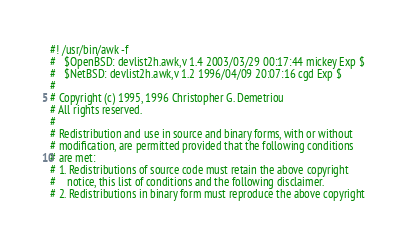Convert code to text. <code><loc_0><loc_0><loc_500><loc_500><_Awk_>#! /usr/bin/awk -f
#	$OpenBSD: devlist2h.awk,v 1.4 2003/03/29 00:17:44 mickey Exp $
#	$NetBSD: devlist2h.awk,v 1.2 1996/04/09 20:07:16 cgd Exp $
#
# Copyright (c) 1995, 1996 Christopher G. Demetriou
# All rights reserved.
#
# Redistribution and use in source and binary forms, with or without
# modification, are permitted provided that the following conditions
# are met:
# 1. Redistributions of source code must retain the above copyright
#    notice, this list of conditions and the following disclaimer.
# 2. Redistributions in binary form must reproduce the above copyright</code> 